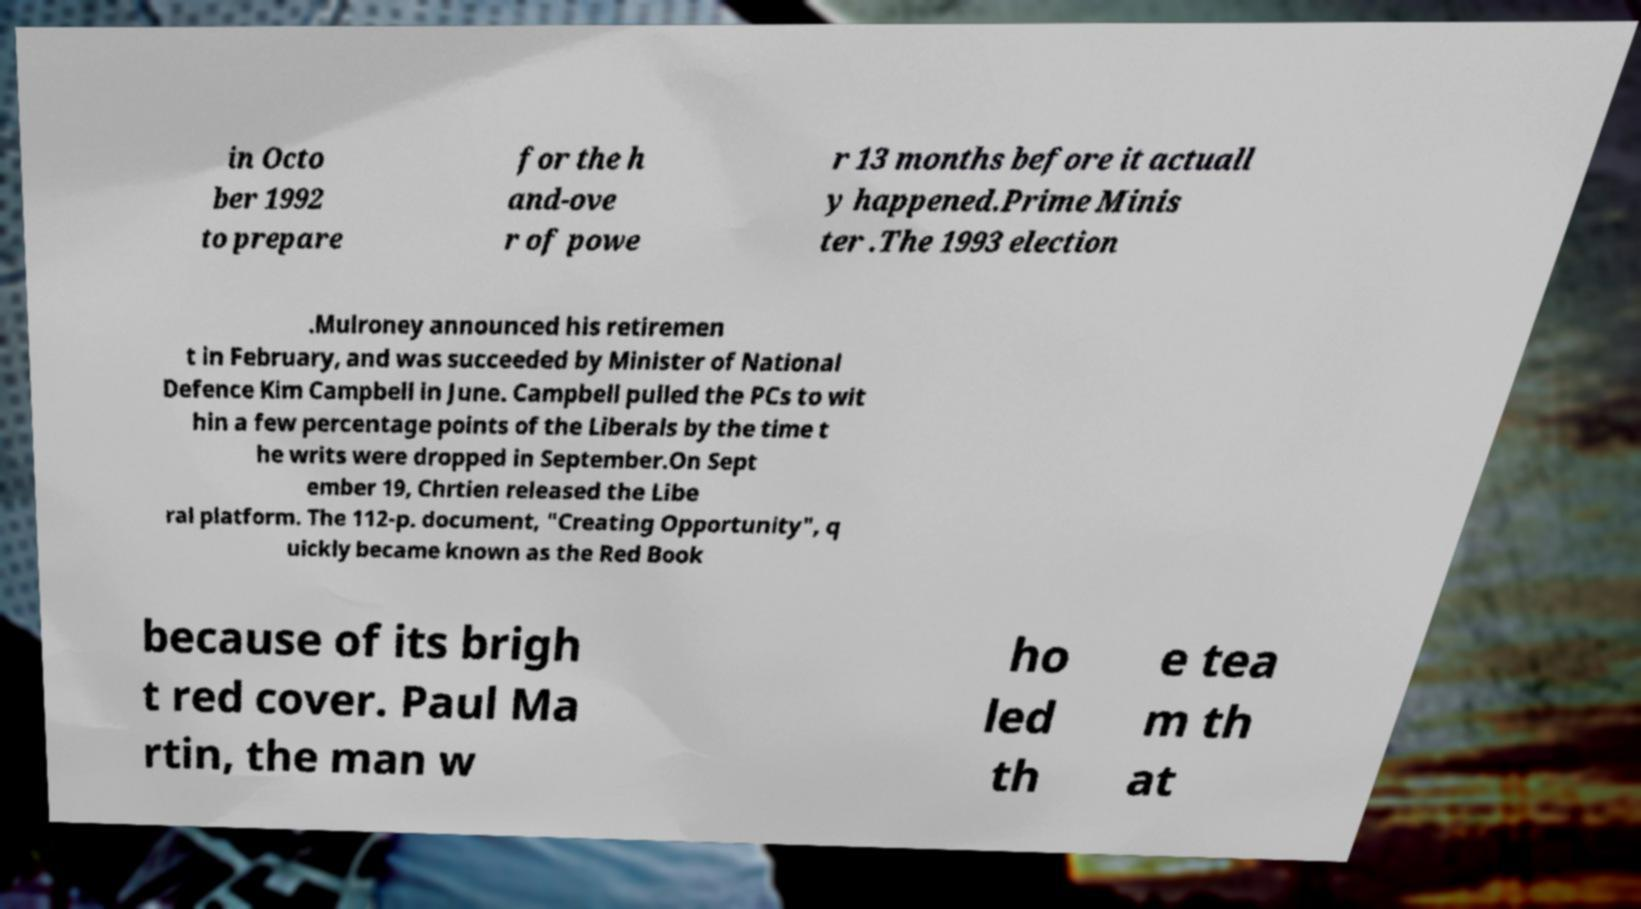Could you extract and type out the text from this image? in Octo ber 1992 to prepare for the h and-ove r of powe r 13 months before it actuall y happened.Prime Minis ter .The 1993 election .Mulroney announced his retiremen t in February, and was succeeded by Minister of National Defence Kim Campbell in June. Campbell pulled the PCs to wit hin a few percentage points of the Liberals by the time t he writs were dropped in September.On Sept ember 19, Chrtien released the Libe ral platform. The 112-p. document, "Creating Opportunity", q uickly became known as the Red Book because of its brigh t red cover. Paul Ma rtin, the man w ho led th e tea m th at 